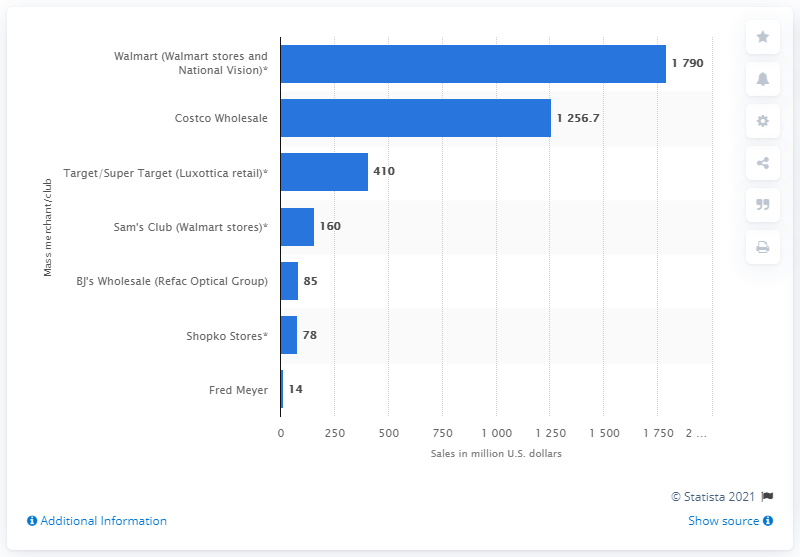Highlight a few significant elements in this photo. In 2019, Costco Wholesale was the second highest ranked mass merchant/club with an optical department in the United States. 